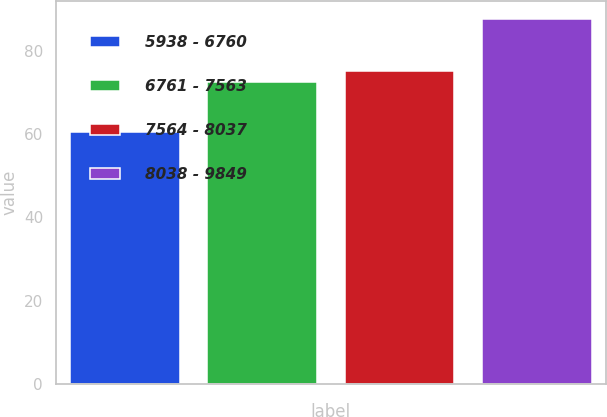<chart> <loc_0><loc_0><loc_500><loc_500><bar_chart><fcel>5938 - 6760<fcel>6761 - 7563<fcel>7564 - 8037<fcel>8038 - 9849<nl><fcel>60.46<fcel>72.4<fcel>75.1<fcel>87.46<nl></chart> 